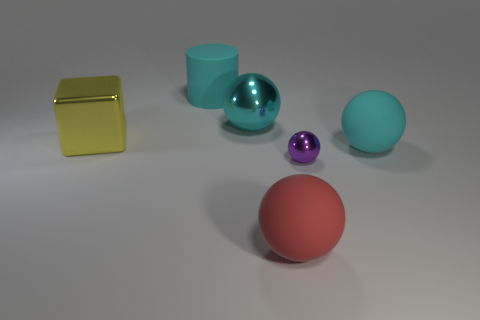Add 3 large brown metal blocks. How many objects exist? 9 Subtract all large balls. How many balls are left? 1 Subtract all purple spheres. How many spheres are left? 3 Subtract all tiny brown metallic blocks. Subtract all cyan objects. How many objects are left? 3 Add 4 shiny spheres. How many shiny spheres are left? 6 Add 2 cyan cylinders. How many cyan cylinders exist? 3 Subtract 0 cyan blocks. How many objects are left? 6 Subtract all balls. How many objects are left? 2 Subtract 1 balls. How many balls are left? 3 Subtract all yellow balls. Subtract all purple cylinders. How many balls are left? 4 